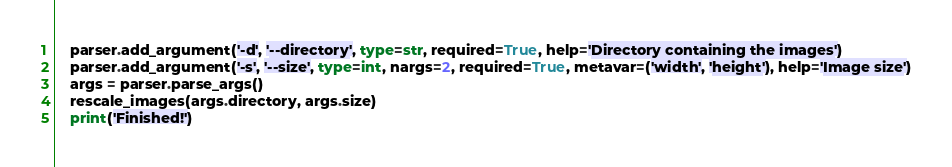Convert code to text. <code><loc_0><loc_0><loc_500><loc_500><_Python_>    parser.add_argument('-d', '--directory', type=str, required=True, help='Directory containing the images')
    parser.add_argument('-s', '--size', type=int, nargs=2, required=True, metavar=('width', 'height'), help='Image size')
    args = parser.parse_args()
    rescale_images(args.directory, args.size)
    print('Finished!')</code> 